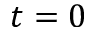<formula> <loc_0><loc_0><loc_500><loc_500>t = 0</formula> 